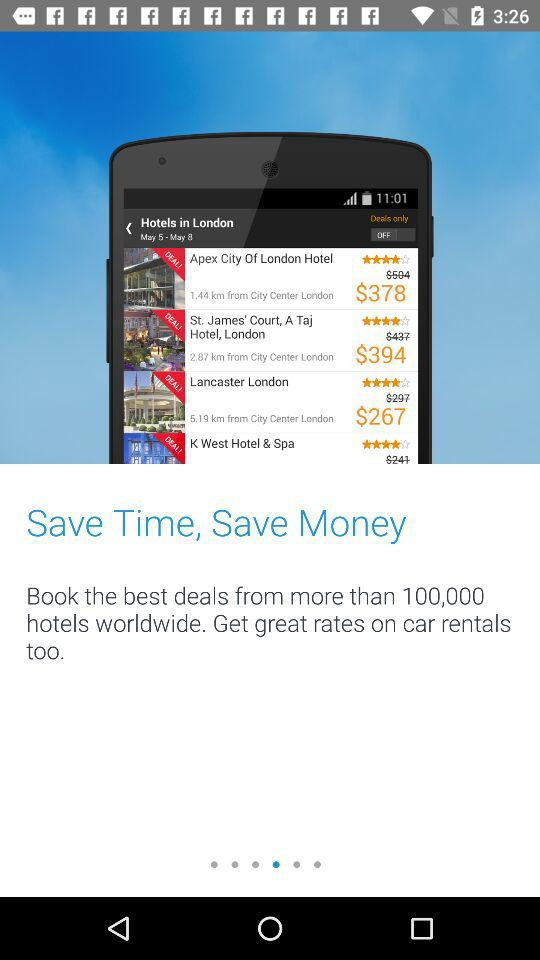What is the cost of Apex City of London Hotel? The cost is $378. 